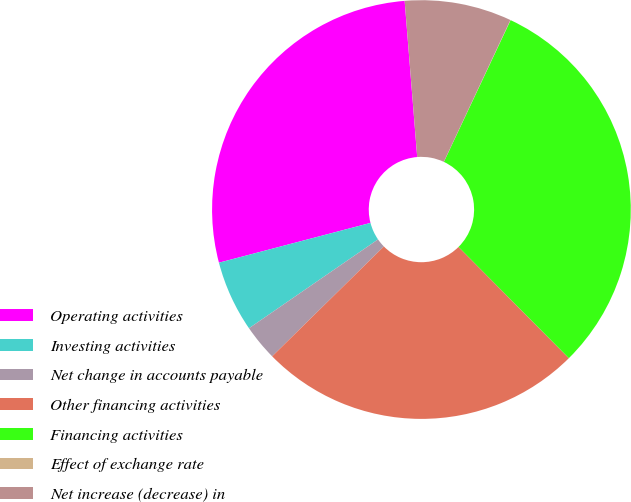Convert chart to OTSL. <chart><loc_0><loc_0><loc_500><loc_500><pie_chart><fcel>Operating activities<fcel>Investing activities<fcel>Net change in accounts payable<fcel>Other financing activities<fcel>Financing activities<fcel>Effect of exchange rate<fcel>Net increase (decrease) in<nl><fcel>27.81%<fcel>5.51%<fcel>2.77%<fcel>25.07%<fcel>30.56%<fcel>0.02%<fcel>8.26%<nl></chart> 